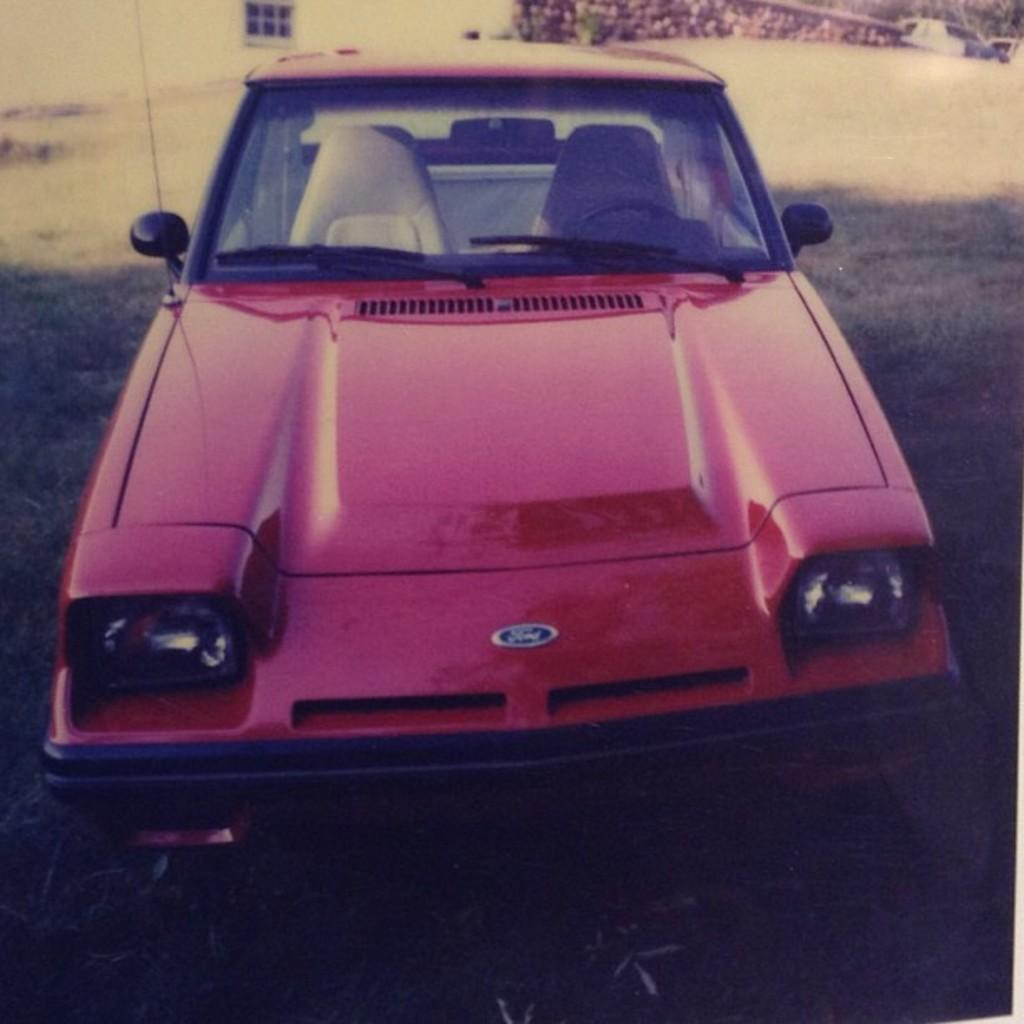What is the main subject of the image? The main subject of the image is a car. How is the car positioned in the image? The car is placed on the ground. What type of natural environment can be seen in the image? There is grass visible in the image. Can you describe any structures in the image? There is a building with a window in the image. What type of duck can be seen wearing a wristband in the image? There is no duck or wristband present in the image. How many dogs are visible in the image? There are no dogs present in the image. 